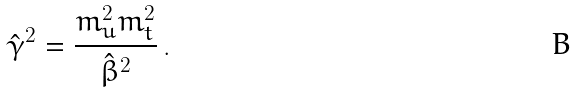<formula> <loc_0><loc_0><loc_500><loc_500>\hat { \gamma } ^ { 2 } = \frac { m _ { u } ^ { 2 } m _ { t } ^ { 2 } } { \hat { \beta } ^ { 2 } } \, .</formula> 